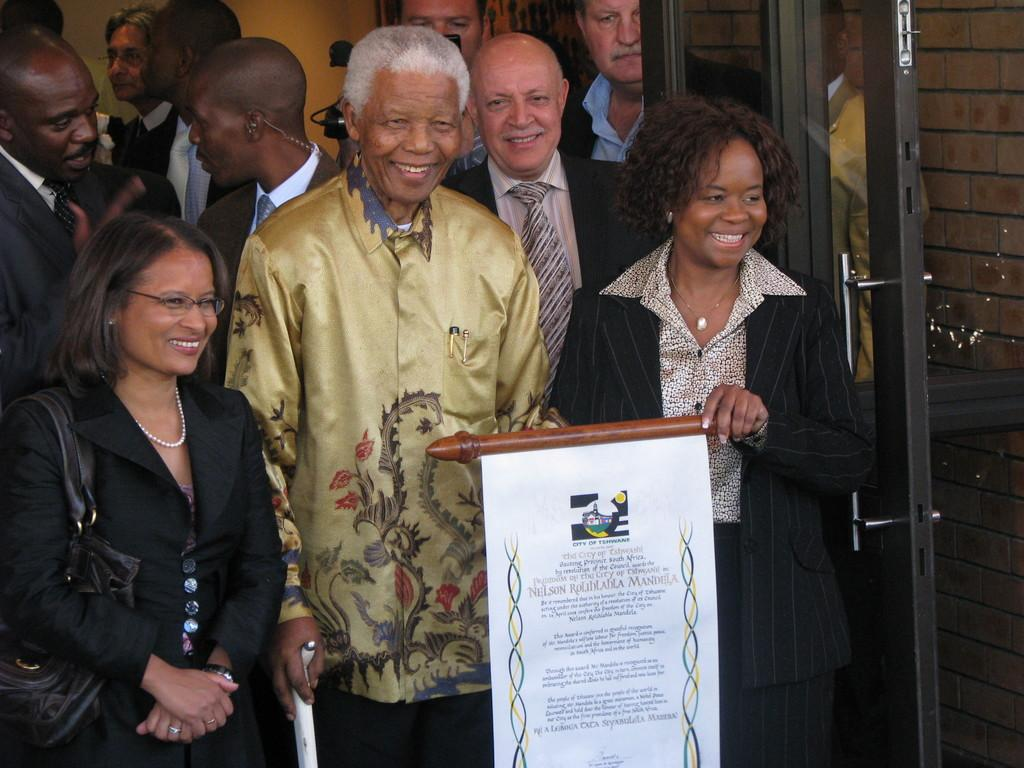How many people are in the image? There are people in the image, but the exact number is not specified. What is one of the structures visible in the image? There is a door in the image. What object is present in the image that has writing on it? There is a board in the image that has some text written on it. How many crows are sitting on the board in the image? There are no crows present in the image. Are there any snakes visible in the image? There is no mention of snakes in the image. Can you see a chain attached to the door in the image? There is no mention of a chain attached to the door in the image. 